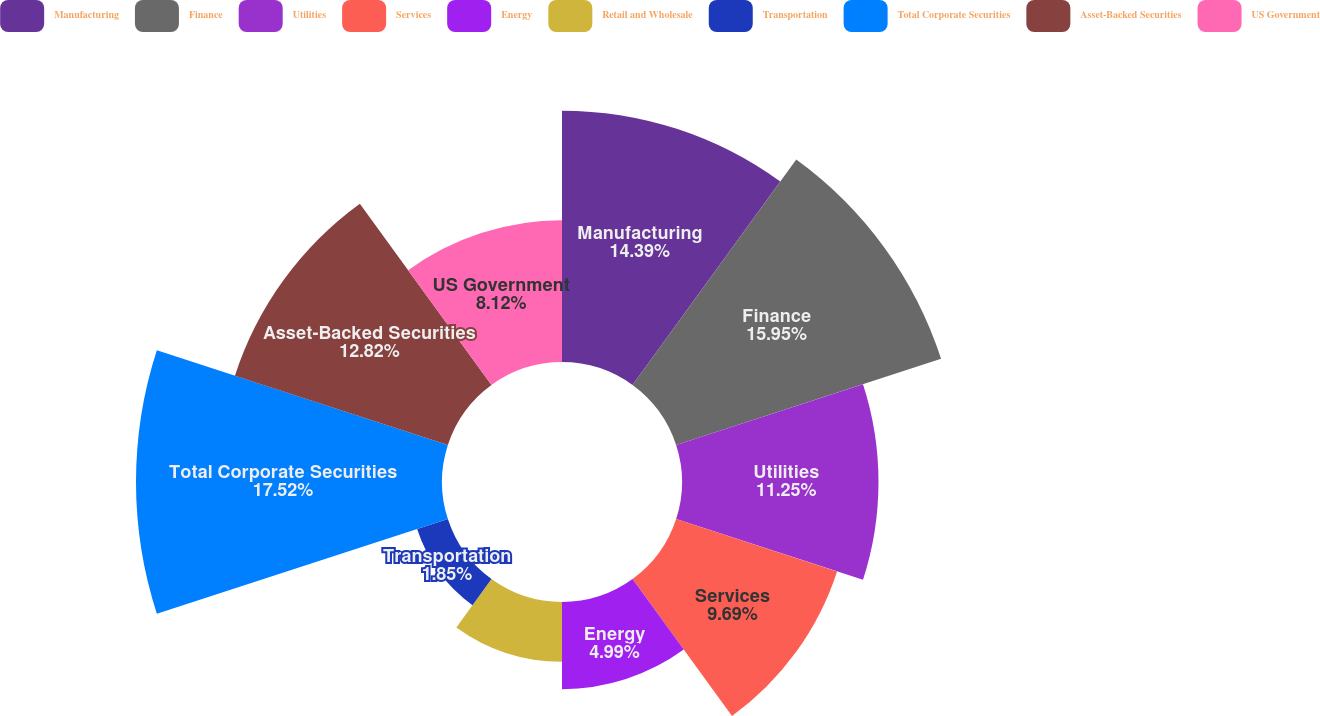Convert chart to OTSL. <chart><loc_0><loc_0><loc_500><loc_500><pie_chart><fcel>Manufacturing<fcel>Finance<fcel>Utilities<fcel>Services<fcel>Energy<fcel>Retail and Wholesale<fcel>Transportation<fcel>Total Corporate Securities<fcel>Asset-Backed Securities<fcel>US Government<nl><fcel>14.39%<fcel>15.95%<fcel>11.25%<fcel>9.69%<fcel>4.99%<fcel>3.42%<fcel>1.85%<fcel>17.52%<fcel>12.82%<fcel>8.12%<nl></chart> 